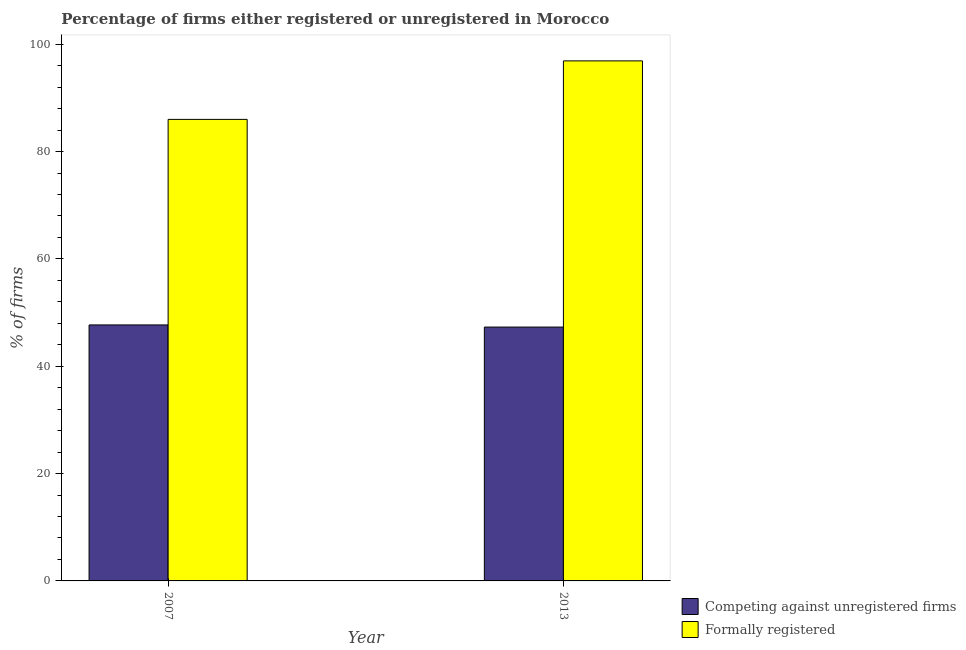How many different coloured bars are there?
Offer a very short reply. 2. Are the number of bars per tick equal to the number of legend labels?
Make the answer very short. Yes. Are the number of bars on each tick of the X-axis equal?
Keep it short and to the point. Yes. How many bars are there on the 2nd tick from the left?
Offer a very short reply. 2. What is the label of the 1st group of bars from the left?
Keep it short and to the point. 2007. What is the percentage of formally registered firms in 2007?
Your response must be concise. 86. Across all years, what is the maximum percentage of formally registered firms?
Give a very brief answer. 96.9. Across all years, what is the minimum percentage of registered firms?
Your response must be concise. 47.3. What is the total percentage of formally registered firms in the graph?
Provide a short and direct response. 182.9. What is the difference between the percentage of registered firms in 2007 and that in 2013?
Ensure brevity in your answer.  0.4. What is the difference between the percentage of formally registered firms in 2013 and the percentage of registered firms in 2007?
Offer a terse response. 10.9. What is the average percentage of registered firms per year?
Provide a succinct answer. 47.5. In how many years, is the percentage of registered firms greater than 60 %?
Provide a short and direct response. 0. What is the ratio of the percentage of registered firms in 2007 to that in 2013?
Offer a terse response. 1.01. Is the percentage of formally registered firms in 2007 less than that in 2013?
Give a very brief answer. Yes. In how many years, is the percentage of formally registered firms greater than the average percentage of formally registered firms taken over all years?
Provide a short and direct response. 1. What does the 1st bar from the left in 2007 represents?
Make the answer very short. Competing against unregistered firms. What does the 1st bar from the right in 2013 represents?
Offer a terse response. Formally registered. How many bars are there?
Provide a short and direct response. 4. What is the difference between two consecutive major ticks on the Y-axis?
Offer a very short reply. 20. Where does the legend appear in the graph?
Make the answer very short. Bottom right. How many legend labels are there?
Make the answer very short. 2. How are the legend labels stacked?
Offer a very short reply. Vertical. What is the title of the graph?
Give a very brief answer. Percentage of firms either registered or unregistered in Morocco. Does "Passenger Transport Items" appear as one of the legend labels in the graph?
Your answer should be very brief. No. What is the label or title of the X-axis?
Keep it short and to the point. Year. What is the label or title of the Y-axis?
Your answer should be compact. % of firms. What is the % of firms in Competing against unregistered firms in 2007?
Your answer should be compact. 47.7. What is the % of firms in Formally registered in 2007?
Your response must be concise. 86. What is the % of firms in Competing against unregistered firms in 2013?
Provide a short and direct response. 47.3. What is the % of firms in Formally registered in 2013?
Ensure brevity in your answer.  96.9. Across all years, what is the maximum % of firms of Competing against unregistered firms?
Offer a terse response. 47.7. Across all years, what is the maximum % of firms of Formally registered?
Offer a terse response. 96.9. Across all years, what is the minimum % of firms in Competing against unregistered firms?
Your response must be concise. 47.3. What is the total % of firms of Competing against unregistered firms in the graph?
Your answer should be very brief. 95. What is the total % of firms of Formally registered in the graph?
Offer a terse response. 182.9. What is the difference between the % of firms in Competing against unregistered firms in 2007 and that in 2013?
Your answer should be very brief. 0.4. What is the difference between the % of firms of Competing against unregistered firms in 2007 and the % of firms of Formally registered in 2013?
Give a very brief answer. -49.2. What is the average % of firms in Competing against unregistered firms per year?
Your response must be concise. 47.5. What is the average % of firms of Formally registered per year?
Make the answer very short. 91.45. In the year 2007, what is the difference between the % of firms of Competing against unregistered firms and % of firms of Formally registered?
Your answer should be compact. -38.3. In the year 2013, what is the difference between the % of firms of Competing against unregistered firms and % of firms of Formally registered?
Ensure brevity in your answer.  -49.6. What is the ratio of the % of firms of Competing against unregistered firms in 2007 to that in 2013?
Ensure brevity in your answer.  1.01. What is the ratio of the % of firms of Formally registered in 2007 to that in 2013?
Provide a succinct answer. 0.89. What is the difference between the highest and the lowest % of firms of Competing against unregistered firms?
Your answer should be very brief. 0.4. What is the difference between the highest and the lowest % of firms of Formally registered?
Ensure brevity in your answer.  10.9. 